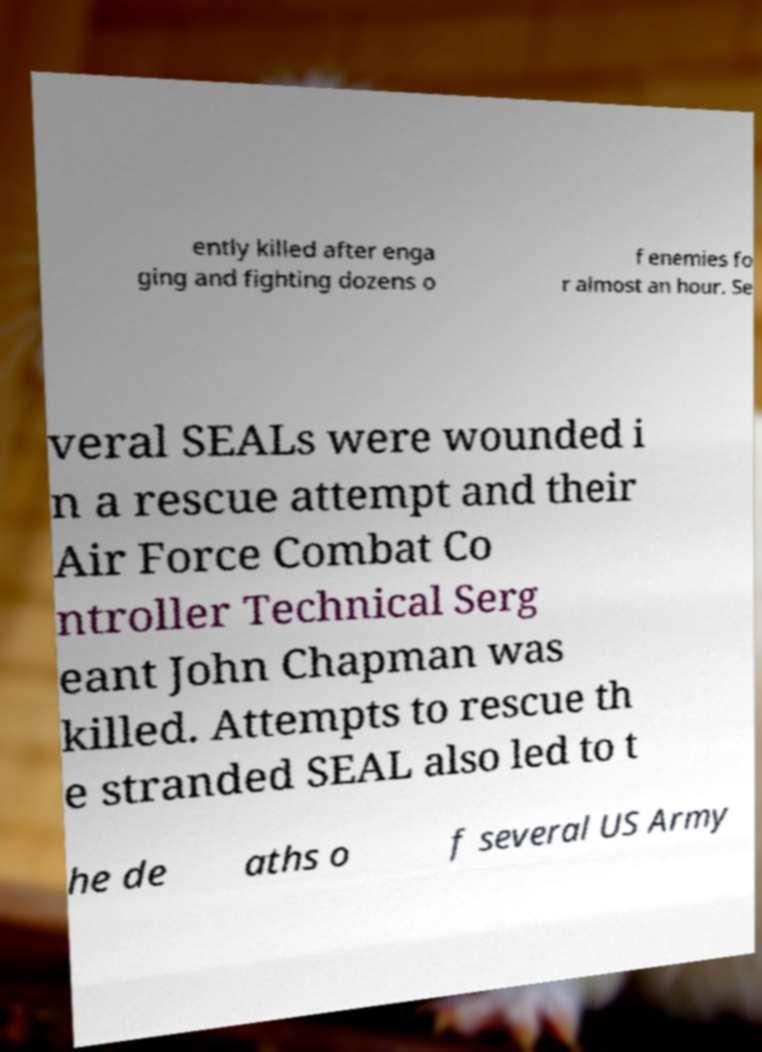I need the written content from this picture converted into text. Can you do that? ently killed after enga ging and fighting dozens o f enemies fo r almost an hour. Se veral SEALs were wounded i n a rescue attempt and their Air Force Combat Co ntroller Technical Serg eant John Chapman was killed. Attempts to rescue th e stranded SEAL also led to t he de aths o f several US Army 